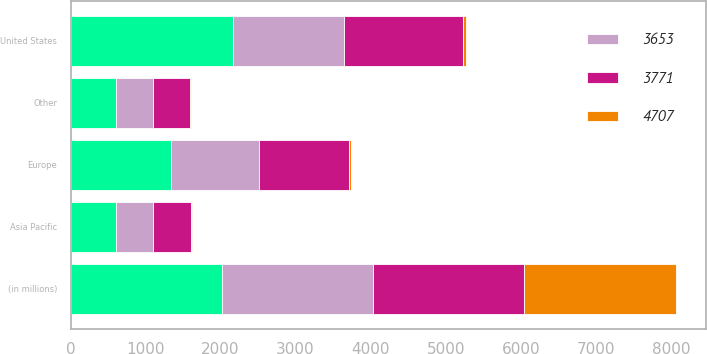Convert chart. <chart><loc_0><loc_0><loc_500><loc_500><stacked_bar_chart><ecel><fcel>(in millions)<fcel>United States<fcel>Europe<fcel>Asia Pacific<fcel>Other<nl><fcel>nan<fcel>2017<fcel>2161<fcel>1335<fcel>611<fcel>600<nl><fcel>4707<fcel>2017<fcel>46<fcel>28<fcel>13<fcel>13<nl><fcel>3771<fcel>2016<fcel>1574<fcel>1195<fcel>518<fcel>484<nl><fcel>3653<fcel>2015<fcel>1490<fcel>1179<fcel>482<fcel>502<nl></chart> 